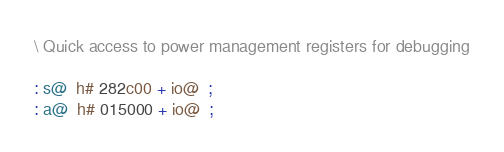<code> <loc_0><loc_0><loc_500><loc_500><_Forth_>\ Quick access to power management registers for debugging

: s@  h# 282c00 + io@  ;
: a@  h# 015000 + io@  ;</code> 